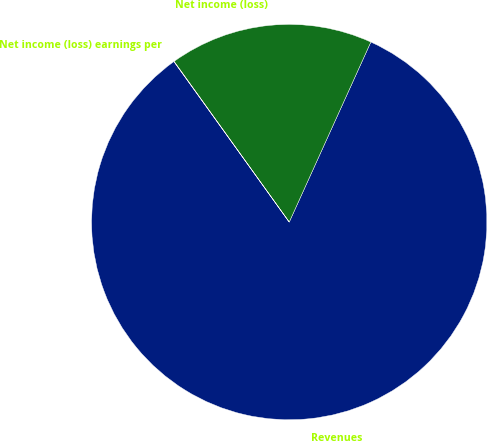<chart> <loc_0><loc_0><loc_500><loc_500><pie_chart><fcel>Revenues<fcel>Net income (loss)<fcel>Net income (loss) earnings per<nl><fcel>83.31%<fcel>16.67%<fcel>0.02%<nl></chart> 